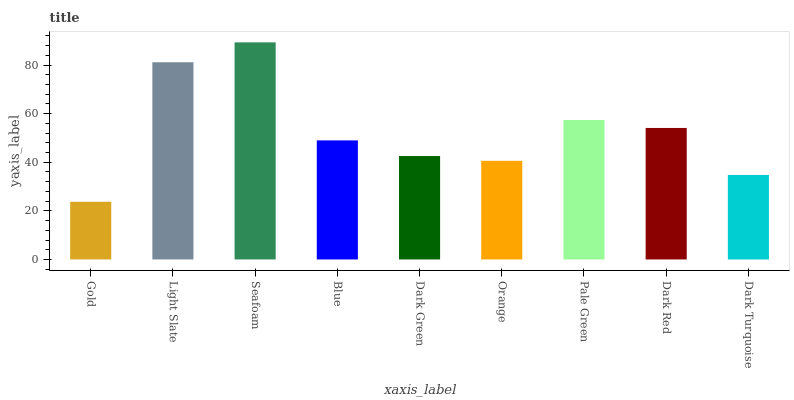Is Gold the minimum?
Answer yes or no. Yes. Is Seafoam the maximum?
Answer yes or no. Yes. Is Light Slate the minimum?
Answer yes or no. No. Is Light Slate the maximum?
Answer yes or no. No. Is Light Slate greater than Gold?
Answer yes or no. Yes. Is Gold less than Light Slate?
Answer yes or no. Yes. Is Gold greater than Light Slate?
Answer yes or no. No. Is Light Slate less than Gold?
Answer yes or no. No. Is Blue the high median?
Answer yes or no. Yes. Is Blue the low median?
Answer yes or no. Yes. Is Dark Red the high median?
Answer yes or no. No. Is Gold the low median?
Answer yes or no. No. 